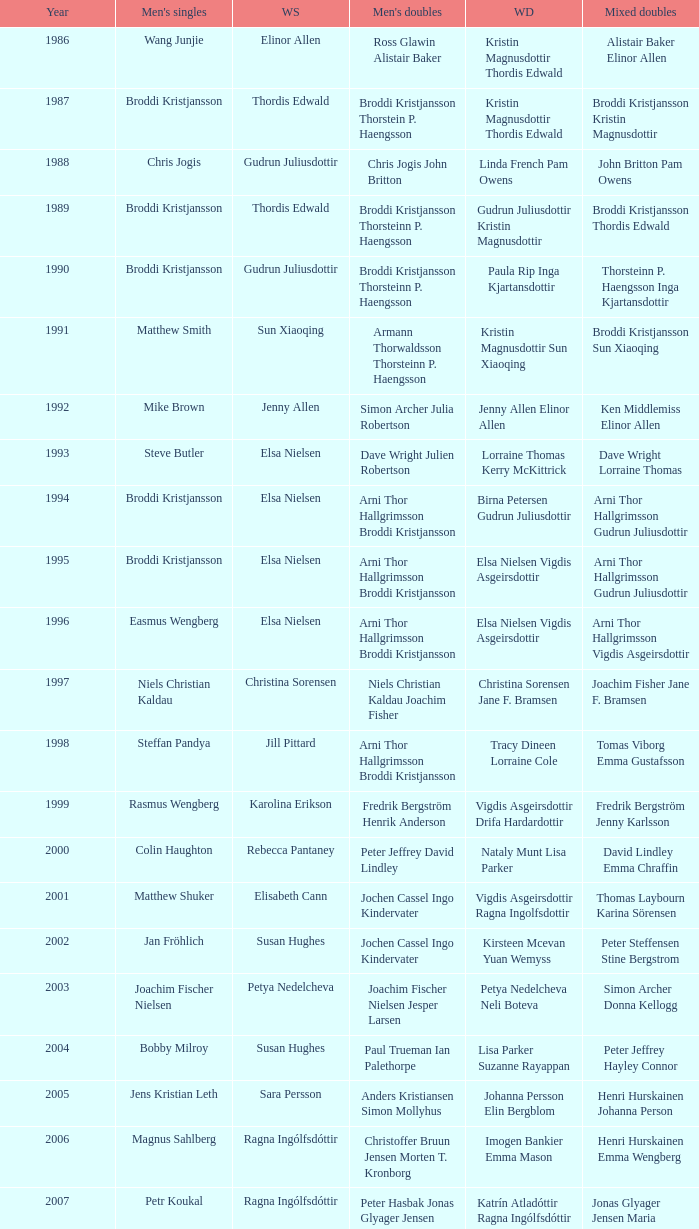In what mixed doubles did Niels Christian Kaldau play in men's singles? Joachim Fisher Jane F. Bramsen. 